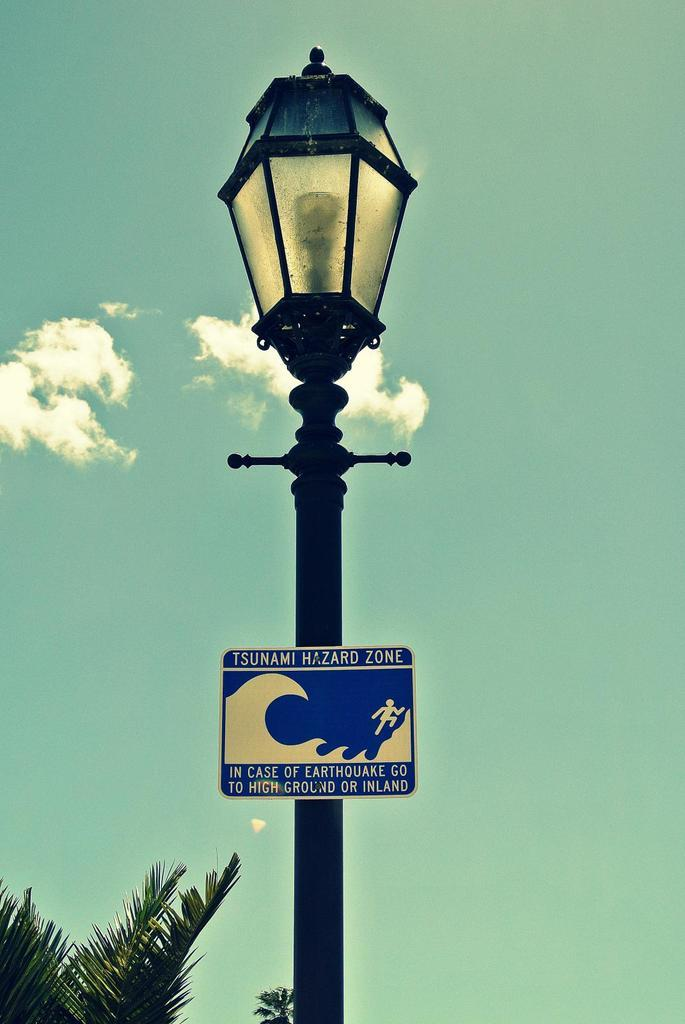What is the main object in the image? There is a pole in the image. What is the color of the board in the image? There is a blue color board in the image. What can be seen attached to the pole? There is a light in the image. What is visible in the sky in the image? Clouds and the sky are visible in the image. What type of vegetation is present in the image? Green color leaves are present in the image. What is written on the blue color board? There is writing on the blue color board. What type of space exploration is depicted on the board in the image? There is no space exploration depicted on the board in the image; it only has writing on it. How does the earthquake affect the pole in the image? There is no earthquake present in the image, so its effect on the pole cannot be determined. 